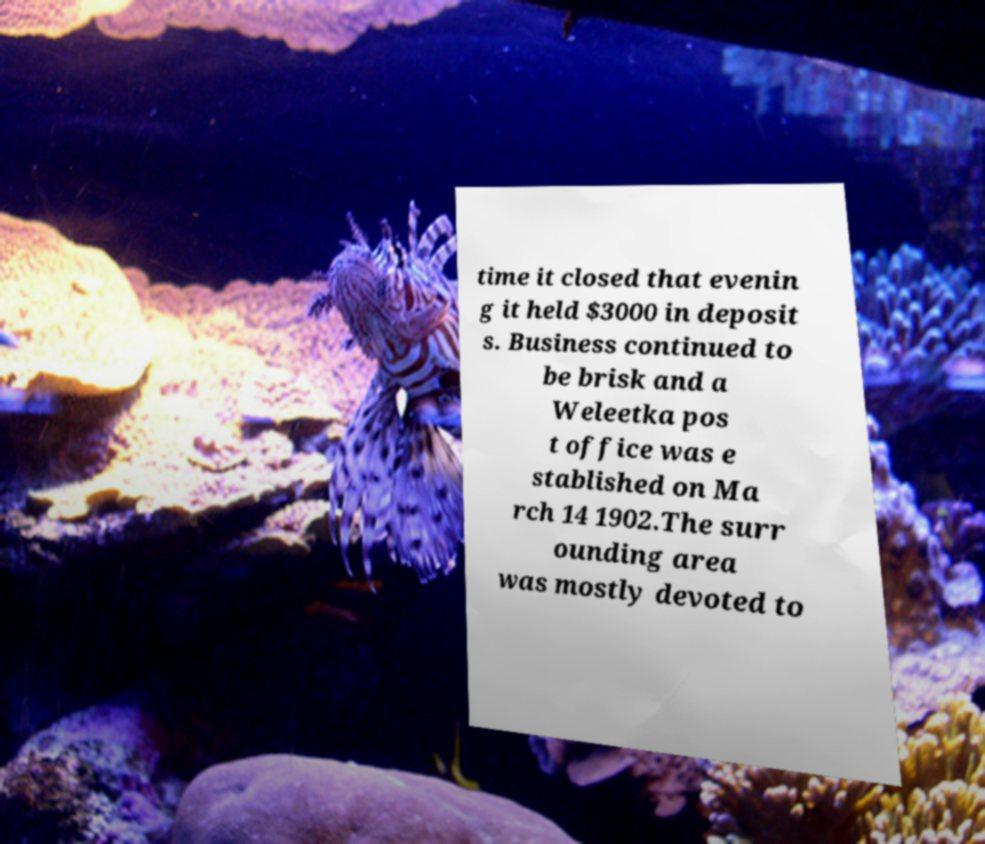Please read and relay the text visible in this image. What does it say? time it closed that evenin g it held $3000 in deposit s. Business continued to be brisk and a Weleetka pos t office was e stablished on Ma rch 14 1902.The surr ounding area was mostly devoted to 